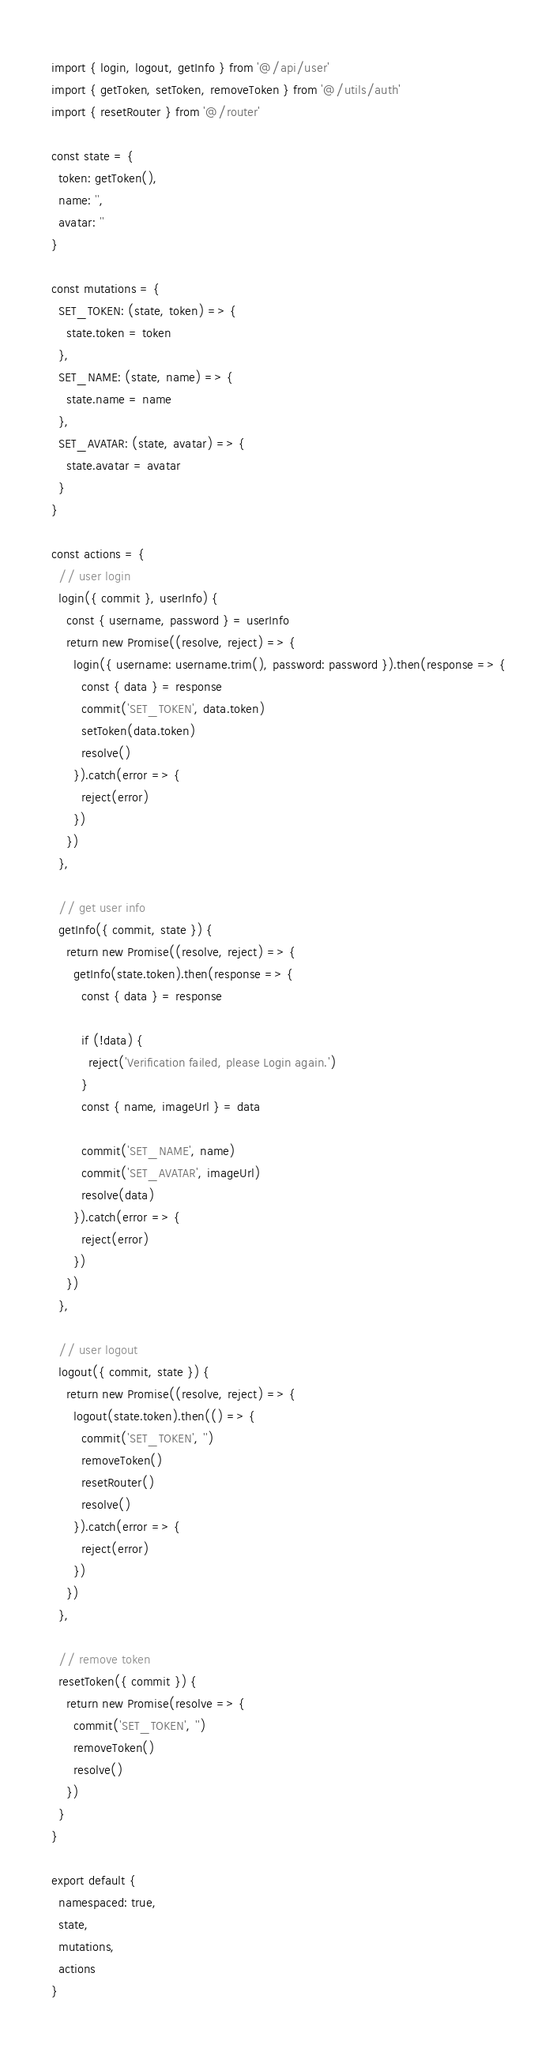<code> <loc_0><loc_0><loc_500><loc_500><_JavaScript_>import { login, logout, getInfo } from '@/api/user'
import { getToken, setToken, removeToken } from '@/utils/auth'
import { resetRouter } from '@/router'

const state = {
  token: getToken(),
  name: '',
  avatar: ''
}

const mutations = {
  SET_TOKEN: (state, token) => {
    state.token = token
  },
  SET_NAME: (state, name) => {
    state.name = name
  },
  SET_AVATAR: (state, avatar) => {
    state.avatar = avatar
  }
}

const actions = {
  // user login
  login({ commit }, userInfo) {
    const { username, password } = userInfo
    return new Promise((resolve, reject) => {
      login({ username: username.trim(), password: password }).then(response => {
        const { data } = response
        commit('SET_TOKEN', data.token)
        setToken(data.token)
        resolve()
      }).catch(error => {
        reject(error)
      })
    })
  },

  // get user info
  getInfo({ commit, state }) {
    return new Promise((resolve, reject) => {
      getInfo(state.token).then(response => {
        const { data } = response

        if (!data) {
          reject('Verification failed, please Login again.')
        }
        const { name, imageUrl } = data

        commit('SET_NAME', name)
        commit('SET_AVATAR', imageUrl)
        resolve(data)
      }).catch(error => {
        reject(error)
      })
    })
  },

  // user logout
  logout({ commit, state }) {
    return new Promise((resolve, reject) => {
      logout(state.token).then(() => {
        commit('SET_TOKEN', '')
        removeToken()
        resetRouter()
        resolve()
      }).catch(error => {
        reject(error)
      })
    })
  },

  // remove token
  resetToken({ commit }) {
    return new Promise(resolve => {
      commit('SET_TOKEN', '')
      removeToken()
      resolve()
    })
  }
}

export default {
  namespaced: true,
  state,
  mutations,
  actions
}

</code> 